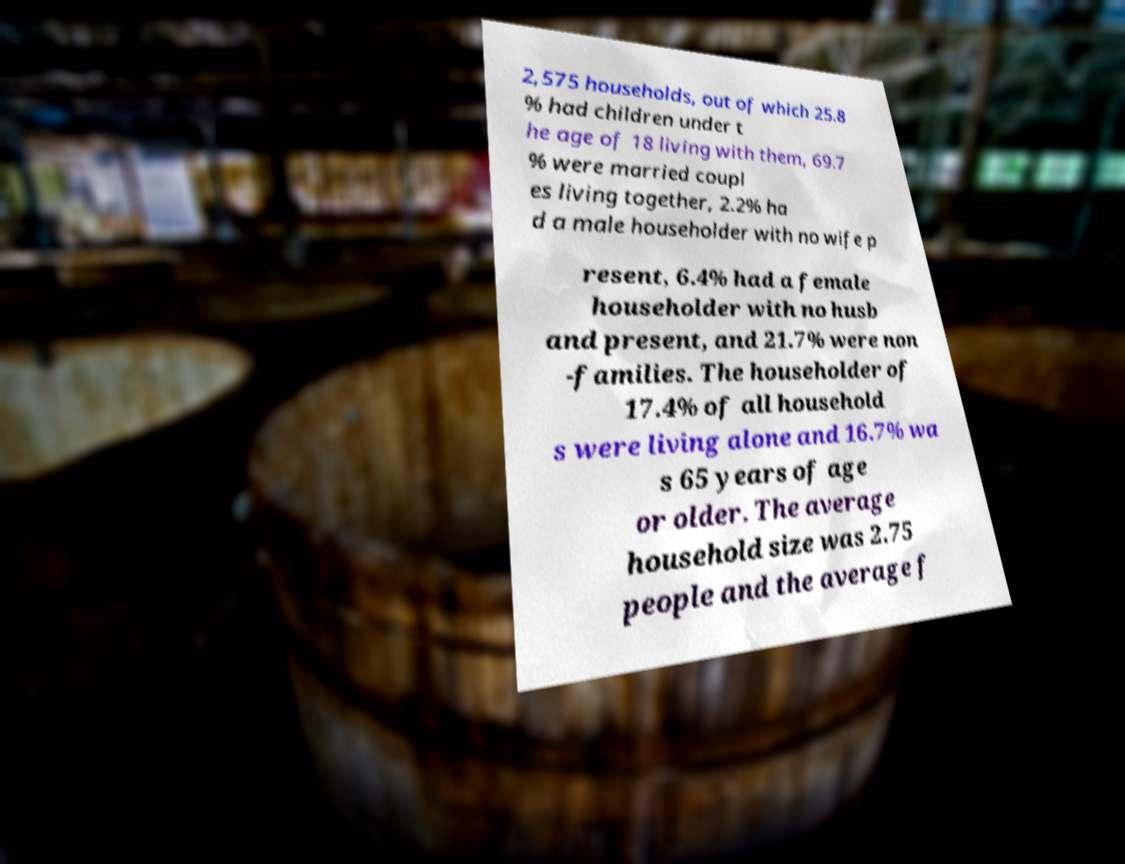There's text embedded in this image that I need extracted. Can you transcribe it verbatim? 2,575 households, out of which 25.8 % had children under t he age of 18 living with them, 69.7 % were married coupl es living together, 2.2% ha d a male householder with no wife p resent, 6.4% had a female householder with no husb and present, and 21.7% were non -families. The householder of 17.4% of all household s were living alone and 16.7% wa s 65 years of age or older. The average household size was 2.75 people and the average f 